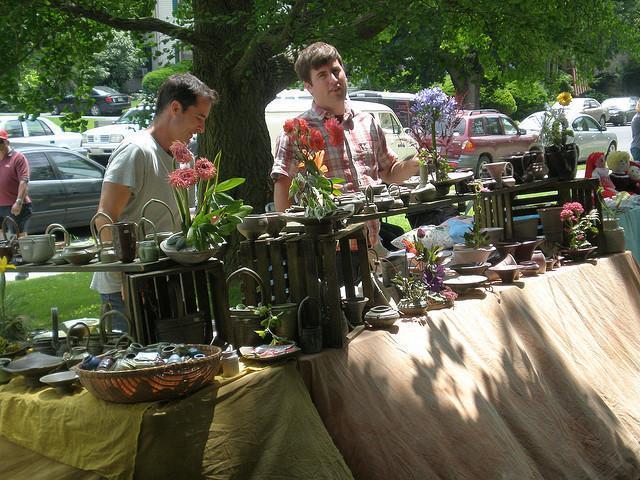How many people are there?
Give a very brief answer. 3. How many dining tables are there?
Give a very brief answer. 2. How many potted plants are in the photo?
Give a very brief answer. 3. How many cars are in the picture?
Give a very brief answer. 4. How many bears have exposed paws?
Give a very brief answer. 0. 